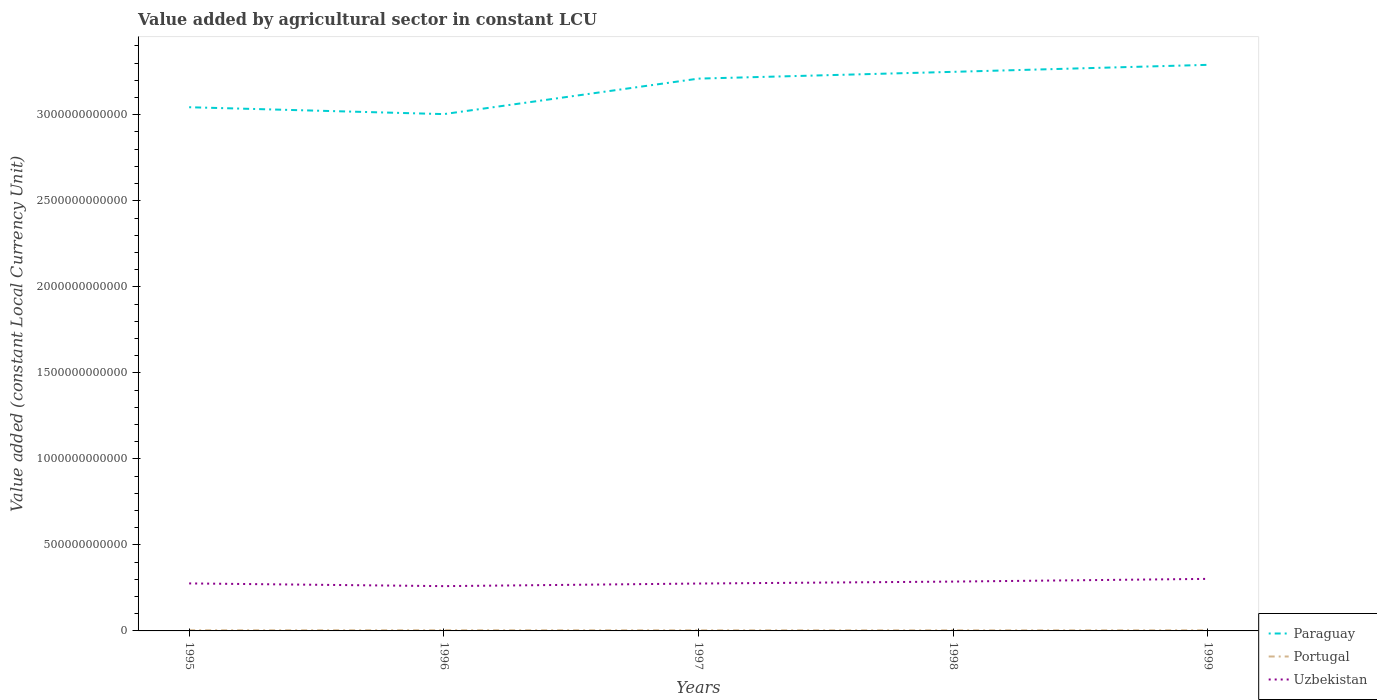How many different coloured lines are there?
Your answer should be compact. 3. Does the line corresponding to Paraguay intersect with the line corresponding to Portugal?
Your response must be concise. No. Across all years, what is the maximum value added by agricultural sector in Uzbekistan?
Offer a terse response. 2.60e+11. In which year was the value added by agricultural sector in Uzbekistan maximum?
Give a very brief answer. 1996. What is the total value added by agricultural sector in Paraguay in the graph?
Provide a short and direct response. -2.06e+11. What is the difference between the highest and the second highest value added by agricultural sector in Paraguay?
Ensure brevity in your answer.  2.86e+11. How many lines are there?
Offer a very short reply. 3. What is the difference between two consecutive major ticks on the Y-axis?
Your answer should be compact. 5.00e+11. How many legend labels are there?
Your answer should be compact. 3. How are the legend labels stacked?
Offer a very short reply. Vertical. What is the title of the graph?
Offer a terse response. Value added by agricultural sector in constant LCU. What is the label or title of the X-axis?
Your response must be concise. Years. What is the label or title of the Y-axis?
Keep it short and to the point. Value added (constant Local Currency Unit). What is the Value added (constant Local Currency Unit) of Paraguay in 1995?
Keep it short and to the point. 3.04e+12. What is the Value added (constant Local Currency Unit) in Portugal in 1995?
Provide a succinct answer. 3.77e+09. What is the Value added (constant Local Currency Unit) in Uzbekistan in 1995?
Your answer should be compact. 2.76e+11. What is the Value added (constant Local Currency Unit) of Paraguay in 1996?
Provide a succinct answer. 3.00e+12. What is the Value added (constant Local Currency Unit) of Portugal in 1996?
Make the answer very short. 3.95e+09. What is the Value added (constant Local Currency Unit) of Uzbekistan in 1996?
Provide a succinct answer. 2.60e+11. What is the Value added (constant Local Currency Unit) of Paraguay in 1997?
Make the answer very short. 3.21e+12. What is the Value added (constant Local Currency Unit) in Portugal in 1997?
Your answer should be compact. 3.64e+09. What is the Value added (constant Local Currency Unit) in Uzbekistan in 1997?
Offer a terse response. 2.75e+11. What is the Value added (constant Local Currency Unit) in Paraguay in 1998?
Make the answer very short. 3.25e+12. What is the Value added (constant Local Currency Unit) of Portugal in 1998?
Make the answer very short. 3.50e+09. What is the Value added (constant Local Currency Unit) in Uzbekistan in 1998?
Keep it short and to the point. 2.87e+11. What is the Value added (constant Local Currency Unit) in Paraguay in 1999?
Provide a succinct answer. 3.29e+12. What is the Value added (constant Local Currency Unit) of Portugal in 1999?
Provide a succinct answer. 3.71e+09. What is the Value added (constant Local Currency Unit) of Uzbekistan in 1999?
Your response must be concise. 3.03e+11. Across all years, what is the maximum Value added (constant Local Currency Unit) in Paraguay?
Your response must be concise. 3.29e+12. Across all years, what is the maximum Value added (constant Local Currency Unit) in Portugal?
Ensure brevity in your answer.  3.95e+09. Across all years, what is the maximum Value added (constant Local Currency Unit) of Uzbekistan?
Offer a very short reply. 3.03e+11. Across all years, what is the minimum Value added (constant Local Currency Unit) of Paraguay?
Your answer should be compact. 3.00e+12. Across all years, what is the minimum Value added (constant Local Currency Unit) in Portugal?
Your response must be concise. 3.50e+09. Across all years, what is the minimum Value added (constant Local Currency Unit) of Uzbekistan?
Your response must be concise. 2.60e+11. What is the total Value added (constant Local Currency Unit) in Paraguay in the graph?
Give a very brief answer. 1.58e+13. What is the total Value added (constant Local Currency Unit) of Portugal in the graph?
Make the answer very short. 1.86e+1. What is the total Value added (constant Local Currency Unit) of Uzbekistan in the graph?
Offer a terse response. 1.40e+12. What is the difference between the Value added (constant Local Currency Unit) in Paraguay in 1995 and that in 1996?
Give a very brief answer. 4.00e+1. What is the difference between the Value added (constant Local Currency Unit) of Portugal in 1995 and that in 1996?
Offer a very short reply. -1.84e+08. What is the difference between the Value added (constant Local Currency Unit) in Uzbekistan in 1995 and that in 1996?
Your answer should be very brief. 1.57e+1. What is the difference between the Value added (constant Local Currency Unit) in Paraguay in 1995 and that in 1997?
Give a very brief answer. -1.66e+11. What is the difference between the Value added (constant Local Currency Unit) in Portugal in 1995 and that in 1997?
Ensure brevity in your answer.  1.28e+08. What is the difference between the Value added (constant Local Currency Unit) in Uzbekistan in 1995 and that in 1997?
Offer a very short reply. 6.37e+08. What is the difference between the Value added (constant Local Currency Unit) in Paraguay in 1995 and that in 1998?
Offer a very short reply. -2.06e+11. What is the difference between the Value added (constant Local Currency Unit) in Portugal in 1995 and that in 1998?
Ensure brevity in your answer.  2.73e+08. What is the difference between the Value added (constant Local Currency Unit) in Uzbekistan in 1995 and that in 1998?
Keep it short and to the point. -1.07e+1. What is the difference between the Value added (constant Local Currency Unit) of Paraguay in 1995 and that in 1999?
Your answer should be compact. -2.46e+11. What is the difference between the Value added (constant Local Currency Unit) of Portugal in 1995 and that in 1999?
Keep it short and to the point. 5.97e+07. What is the difference between the Value added (constant Local Currency Unit) of Uzbekistan in 1995 and that in 1999?
Your answer should be compact. -2.64e+1. What is the difference between the Value added (constant Local Currency Unit) in Paraguay in 1996 and that in 1997?
Your answer should be very brief. -2.06e+11. What is the difference between the Value added (constant Local Currency Unit) of Portugal in 1996 and that in 1997?
Offer a terse response. 3.12e+08. What is the difference between the Value added (constant Local Currency Unit) of Uzbekistan in 1996 and that in 1997?
Ensure brevity in your answer.  -1.51e+1. What is the difference between the Value added (constant Local Currency Unit) of Paraguay in 1996 and that in 1998?
Provide a succinct answer. -2.46e+11. What is the difference between the Value added (constant Local Currency Unit) in Portugal in 1996 and that in 1998?
Make the answer very short. 4.57e+08. What is the difference between the Value added (constant Local Currency Unit) in Uzbekistan in 1996 and that in 1998?
Keep it short and to the point. -2.64e+1. What is the difference between the Value added (constant Local Currency Unit) in Paraguay in 1996 and that in 1999?
Your response must be concise. -2.86e+11. What is the difference between the Value added (constant Local Currency Unit) in Portugal in 1996 and that in 1999?
Give a very brief answer. 2.44e+08. What is the difference between the Value added (constant Local Currency Unit) in Uzbekistan in 1996 and that in 1999?
Provide a short and direct response. -4.22e+1. What is the difference between the Value added (constant Local Currency Unit) in Paraguay in 1997 and that in 1998?
Offer a very short reply. -3.94e+1. What is the difference between the Value added (constant Local Currency Unit) in Portugal in 1997 and that in 1998?
Give a very brief answer. 1.44e+08. What is the difference between the Value added (constant Local Currency Unit) of Uzbekistan in 1997 and that in 1998?
Your answer should be very brief. -1.13e+1. What is the difference between the Value added (constant Local Currency Unit) of Paraguay in 1997 and that in 1999?
Make the answer very short. -8.01e+1. What is the difference between the Value added (constant Local Currency Unit) in Portugal in 1997 and that in 1999?
Your answer should be very brief. -6.87e+07. What is the difference between the Value added (constant Local Currency Unit) in Uzbekistan in 1997 and that in 1999?
Make the answer very short. -2.71e+1. What is the difference between the Value added (constant Local Currency Unit) of Paraguay in 1998 and that in 1999?
Make the answer very short. -4.06e+1. What is the difference between the Value added (constant Local Currency Unit) in Portugal in 1998 and that in 1999?
Give a very brief answer. -2.13e+08. What is the difference between the Value added (constant Local Currency Unit) in Uzbekistan in 1998 and that in 1999?
Provide a succinct answer. -1.58e+1. What is the difference between the Value added (constant Local Currency Unit) in Paraguay in 1995 and the Value added (constant Local Currency Unit) in Portugal in 1996?
Your answer should be very brief. 3.04e+12. What is the difference between the Value added (constant Local Currency Unit) in Paraguay in 1995 and the Value added (constant Local Currency Unit) in Uzbekistan in 1996?
Ensure brevity in your answer.  2.78e+12. What is the difference between the Value added (constant Local Currency Unit) of Portugal in 1995 and the Value added (constant Local Currency Unit) of Uzbekistan in 1996?
Offer a terse response. -2.57e+11. What is the difference between the Value added (constant Local Currency Unit) in Paraguay in 1995 and the Value added (constant Local Currency Unit) in Portugal in 1997?
Your response must be concise. 3.04e+12. What is the difference between the Value added (constant Local Currency Unit) of Paraguay in 1995 and the Value added (constant Local Currency Unit) of Uzbekistan in 1997?
Keep it short and to the point. 2.77e+12. What is the difference between the Value added (constant Local Currency Unit) in Portugal in 1995 and the Value added (constant Local Currency Unit) in Uzbekistan in 1997?
Your answer should be very brief. -2.72e+11. What is the difference between the Value added (constant Local Currency Unit) in Paraguay in 1995 and the Value added (constant Local Currency Unit) in Portugal in 1998?
Your response must be concise. 3.04e+12. What is the difference between the Value added (constant Local Currency Unit) in Paraguay in 1995 and the Value added (constant Local Currency Unit) in Uzbekistan in 1998?
Your answer should be very brief. 2.76e+12. What is the difference between the Value added (constant Local Currency Unit) of Portugal in 1995 and the Value added (constant Local Currency Unit) of Uzbekistan in 1998?
Ensure brevity in your answer.  -2.83e+11. What is the difference between the Value added (constant Local Currency Unit) of Paraguay in 1995 and the Value added (constant Local Currency Unit) of Portugal in 1999?
Make the answer very short. 3.04e+12. What is the difference between the Value added (constant Local Currency Unit) of Paraguay in 1995 and the Value added (constant Local Currency Unit) of Uzbekistan in 1999?
Provide a short and direct response. 2.74e+12. What is the difference between the Value added (constant Local Currency Unit) in Portugal in 1995 and the Value added (constant Local Currency Unit) in Uzbekistan in 1999?
Give a very brief answer. -2.99e+11. What is the difference between the Value added (constant Local Currency Unit) in Paraguay in 1996 and the Value added (constant Local Currency Unit) in Portugal in 1997?
Offer a terse response. 3.00e+12. What is the difference between the Value added (constant Local Currency Unit) in Paraguay in 1996 and the Value added (constant Local Currency Unit) in Uzbekistan in 1997?
Give a very brief answer. 2.73e+12. What is the difference between the Value added (constant Local Currency Unit) of Portugal in 1996 and the Value added (constant Local Currency Unit) of Uzbekistan in 1997?
Offer a terse response. -2.71e+11. What is the difference between the Value added (constant Local Currency Unit) in Paraguay in 1996 and the Value added (constant Local Currency Unit) in Portugal in 1998?
Offer a terse response. 3.00e+12. What is the difference between the Value added (constant Local Currency Unit) in Paraguay in 1996 and the Value added (constant Local Currency Unit) in Uzbekistan in 1998?
Make the answer very short. 2.72e+12. What is the difference between the Value added (constant Local Currency Unit) in Portugal in 1996 and the Value added (constant Local Currency Unit) in Uzbekistan in 1998?
Give a very brief answer. -2.83e+11. What is the difference between the Value added (constant Local Currency Unit) in Paraguay in 1996 and the Value added (constant Local Currency Unit) in Portugal in 1999?
Your answer should be very brief. 3.00e+12. What is the difference between the Value added (constant Local Currency Unit) of Paraguay in 1996 and the Value added (constant Local Currency Unit) of Uzbekistan in 1999?
Give a very brief answer. 2.70e+12. What is the difference between the Value added (constant Local Currency Unit) of Portugal in 1996 and the Value added (constant Local Currency Unit) of Uzbekistan in 1999?
Ensure brevity in your answer.  -2.99e+11. What is the difference between the Value added (constant Local Currency Unit) in Paraguay in 1997 and the Value added (constant Local Currency Unit) in Portugal in 1998?
Provide a succinct answer. 3.21e+12. What is the difference between the Value added (constant Local Currency Unit) of Paraguay in 1997 and the Value added (constant Local Currency Unit) of Uzbekistan in 1998?
Provide a short and direct response. 2.92e+12. What is the difference between the Value added (constant Local Currency Unit) of Portugal in 1997 and the Value added (constant Local Currency Unit) of Uzbekistan in 1998?
Ensure brevity in your answer.  -2.83e+11. What is the difference between the Value added (constant Local Currency Unit) in Paraguay in 1997 and the Value added (constant Local Currency Unit) in Portugal in 1999?
Ensure brevity in your answer.  3.21e+12. What is the difference between the Value added (constant Local Currency Unit) of Paraguay in 1997 and the Value added (constant Local Currency Unit) of Uzbekistan in 1999?
Offer a very short reply. 2.91e+12. What is the difference between the Value added (constant Local Currency Unit) of Portugal in 1997 and the Value added (constant Local Currency Unit) of Uzbekistan in 1999?
Provide a succinct answer. -2.99e+11. What is the difference between the Value added (constant Local Currency Unit) of Paraguay in 1998 and the Value added (constant Local Currency Unit) of Portugal in 1999?
Offer a terse response. 3.25e+12. What is the difference between the Value added (constant Local Currency Unit) in Paraguay in 1998 and the Value added (constant Local Currency Unit) in Uzbekistan in 1999?
Give a very brief answer. 2.95e+12. What is the difference between the Value added (constant Local Currency Unit) in Portugal in 1998 and the Value added (constant Local Currency Unit) in Uzbekistan in 1999?
Provide a succinct answer. -2.99e+11. What is the average Value added (constant Local Currency Unit) in Paraguay per year?
Your response must be concise. 3.16e+12. What is the average Value added (constant Local Currency Unit) of Portugal per year?
Keep it short and to the point. 3.71e+09. What is the average Value added (constant Local Currency Unit) in Uzbekistan per year?
Offer a very short reply. 2.80e+11. In the year 1995, what is the difference between the Value added (constant Local Currency Unit) in Paraguay and Value added (constant Local Currency Unit) in Portugal?
Your response must be concise. 3.04e+12. In the year 1995, what is the difference between the Value added (constant Local Currency Unit) in Paraguay and Value added (constant Local Currency Unit) in Uzbekistan?
Offer a very short reply. 2.77e+12. In the year 1995, what is the difference between the Value added (constant Local Currency Unit) of Portugal and Value added (constant Local Currency Unit) of Uzbekistan?
Your response must be concise. -2.72e+11. In the year 1996, what is the difference between the Value added (constant Local Currency Unit) of Paraguay and Value added (constant Local Currency Unit) of Portugal?
Your answer should be very brief. 3.00e+12. In the year 1996, what is the difference between the Value added (constant Local Currency Unit) of Paraguay and Value added (constant Local Currency Unit) of Uzbekistan?
Your answer should be very brief. 2.74e+12. In the year 1996, what is the difference between the Value added (constant Local Currency Unit) of Portugal and Value added (constant Local Currency Unit) of Uzbekistan?
Offer a terse response. -2.56e+11. In the year 1997, what is the difference between the Value added (constant Local Currency Unit) of Paraguay and Value added (constant Local Currency Unit) of Portugal?
Your answer should be very brief. 3.21e+12. In the year 1997, what is the difference between the Value added (constant Local Currency Unit) of Paraguay and Value added (constant Local Currency Unit) of Uzbekistan?
Your answer should be compact. 2.93e+12. In the year 1997, what is the difference between the Value added (constant Local Currency Unit) of Portugal and Value added (constant Local Currency Unit) of Uzbekistan?
Provide a succinct answer. -2.72e+11. In the year 1998, what is the difference between the Value added (constant Local Currency Unit) of Paraguay and Value added (constant Local Currency Unit) of Portugal?
Your response must be concise. 3.25e+12. In the year 1998, what is the difference between the Value added (constant Local Currency Unit) in Paraguay and Value added (constant Local Currency Unit) in Uzbekistan?
Your answer should be very brief. 2.96e+12. In the year 1998, what is the difference between the Value added (constant Local Currency Unit) of Portugal and Value added (constant Local Currency Unit) of Uzbekistan?
Offer a terse response. -2.83e+11. In the year 1999, what is the difference between the Value added (constant Local Currency Unit) of Paraguay and Value added (constant Local Currency Unit) of Portugal?
Your answer should be compact. 3.29e+12. In the year 1999, what is the difference between the Value added (constant Local Currency Unit) in Paraguay and Value added (constant Local Currency Unit) in Uzbekistan?
Your answer should be compact. 2.99e+12. In the year 1999, what is the difference between the Value added (constant Local Currency Unit) of Portugal and Value added (constant Local Currency Unit) of Uzbekistan?
Your response must be concise. -2.99e+11. What is the ratio of the Value added (constant Local Currency Unit) in Paraguay in 1995 to that in 1996?
Offer a very short reply. 1.01. What is the ratio of the Value added (constant Local Currency Unit) of Portugal in 1995 to that in 1996?
Provide a succinct answer. 0.95. What is the ratio of the Value added (constant Local Currency Unit) of Uzbekistan in 1995 to that in 1996?
Offer a terse response. 1.06. What is the ratio of the Value added (constant Local Currency Unit) in Paraguay in 1995 to that in 1997?
Your answer should be very brief. 0.95. What is the ratio of the Value added (constant Local Currency Unit) in Portugal in 1995 to that in 1997?
Make the answer very short. 1.04. What is the ratio of the Value added (constant Local Currency Unit) of Paraguay in 1995 to that in 1998?
Your answer should be very brief. 0.94. What is the ratio of the Value added (constant Local Currency Unit) in Portugal in 1995 to that in 1998?
Offer a very short reply. 1.08. What is the ratio of the Value added (constant Local Currency Unit) of Uzbekistan in 1995 to that in 1998?
Your answer should be compact. 0.96. What is the ratio of the Value added (constant Local Currency Unit) of Paraguay in 1995 to that in 1999?
Offer a terse response. 0.93. What is the ratio of the Value added (constant Local Currency Unit) in Portugal in 1995 to that in 1999?
Provide a short and direct response. 1.02. What is the ratio of the Value added (constant Local Currency Unit) in Uzbekistan in 1995 to that in 1999?
Offer a very short reply. 0.91. What is the ratio of the Value added (constant Local Currency Unit) of Paraguay in 1996 to that in 1997?
Provide a short and direct response. 0.94. What is the ratio of the Value added (constant Local Currency Unit) in Portugal in 1996 to that in 1997?
Offer a terse response. 1.09. What is the ratio of the Value added (constant Local Currency Unit) of Uzbekistan in 1996 to that in 1997?
Make the answer very short. 0.95. What is the ratio of the Value added (constant Local Currency Unit) of Paraguay in 1996 to that in 1998?
Make the answer very short. 0.92. What is the ratio of the Value added (constant Local Currency Unit) in Portugal in 1996 to that in 1998?
Keep it short and to the point. 1.13. What is the ratio of the Value added (constant Local Currency Unit) in Uzbekistan in 1996 to that in 1998?
Your answer should be compact. 0.91. What is the ratio of the Value added (constant Local Currency Unit) in Portugal in 1996 to that in 1999?
Give a very brief answer. 1.07. What is the ratio of the Value added (constant Local Currency Unit) of Uzbekistan in 1996 to that in 1999?
Offer a terse response. 0.86. What is the ratio of the Value added (constant Local Currency Unit) of Paraguay in 1997 to that in 1998?
Your answer should be very brief. 0.99. What is the ratio of the Value added (constant Local Currency Unit) of Portugal in 1997 to that in 1998?
Provide a short and direct response. 1.04. What is the ratio of the Value added (constant Local Currency Unit) of Uzbekistan in 1997 to that in 1998?
Provide a succinct answer. 0.96. What is the ratio of the Value added (constant Local Currency Unit) of Paraguay in 1997 to that in 1999?
Ensure brevity in your answer.  0.98. What is the ratio of the Value added (constant Local Currency Unit) in Portugal in 1997 to that in 1999?
Provide a short and direct response. 0.98. What is the ratio of the Value added (constant Local Currency Unit) in Uzbekistan in 1997 to that in 1999?
Provide a succinct answer. 0.91. What is the ratio of the Value added (constant Local Currency Unit) of Portugal in 1998 to that in 1999?
Provide a succinct answer. 0.94. What is the ratio of the Value added (constant Local Currency Unit) of Uzbekistan in 1998 to that in 1999?
Offer a terse response. 0.95. What is the difference between the highest and the second highest Value added (constant Local Currency Unit) in Paraguay?
Your answer should be compact. 4.06e+1. What is the difference between the highest and the second highest Value added (constant Local Currency Unit) of Portugal?
Keep it short and to the point. 1.84e+08. What is the difference between the highest and the second highest Value added (constant Local Currency Unit) in Uzbekistan?
Keep it short and to the point. 1.58e+1. What is the difference between the highest and the lowest Value added (constant Local Currency Unit) in Paraguay?
Ensure brevity in your answer.  2.86e+11. What is the difference between the highest and the lowest Value added (constant Local Currency Unit) in Portugal?
Offer a very short reply. 4.57e+08. What is the difference between the highest and the lowest Value added (constant Local Currency Unit) of Uzbekistan?
Make the answer very short. 4.22e+1. 